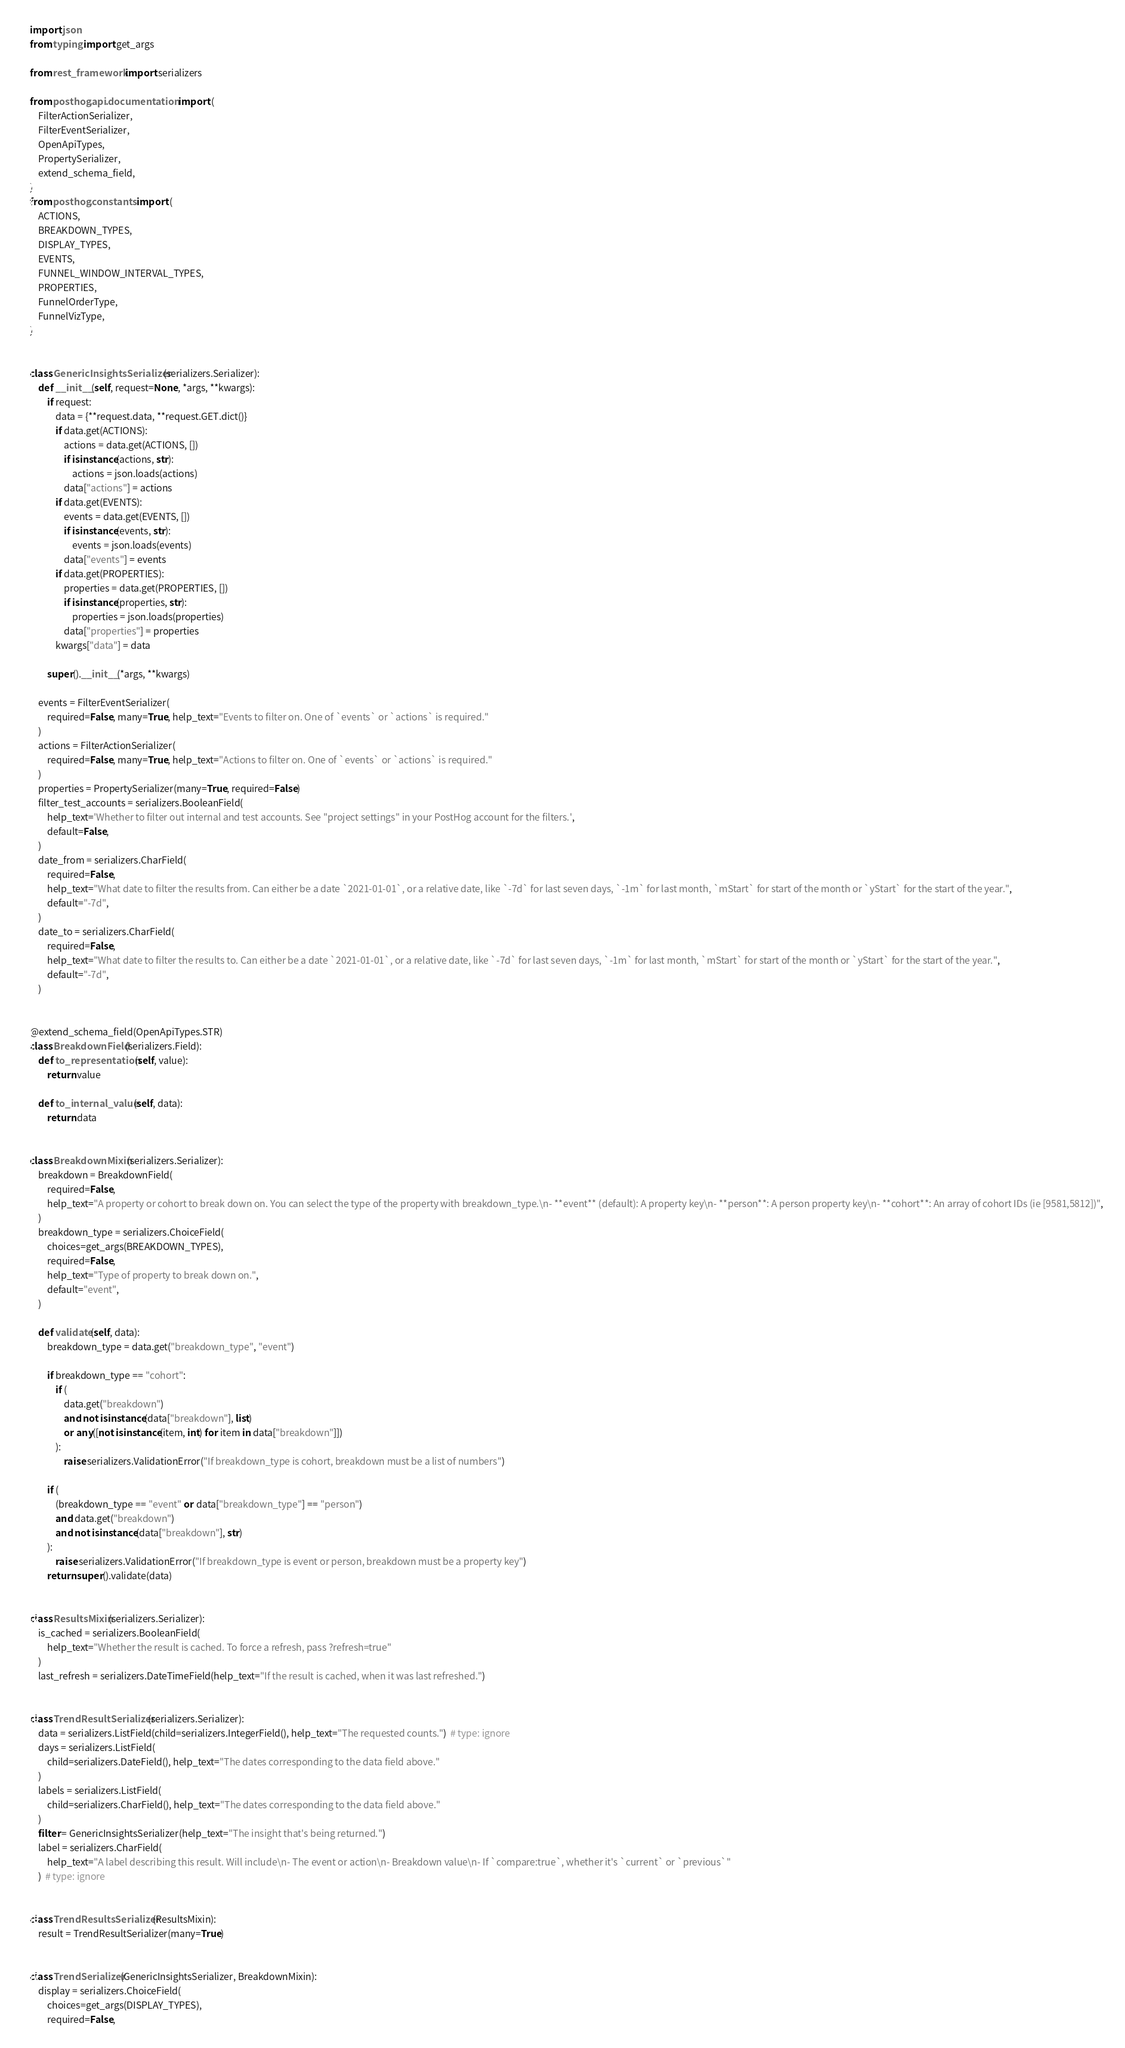<code> <loc_0><loc_0><loc_500><loc_500><_Python_>import json
from typing import get_args

from rest_framework import serializers

from posthog.api.documentation import (
    FilterActionSerializer,
    FilterEventSerializer,
    OpenApiTypes,
    PropertySerializer,
    extend_schema_field,
)
from posthog.constants import (
    ACTIONS,
    BREAKDOWN_TYPES,
    DISPLAY_TYPES,
    EVENTS,
    FUNNEL_WINDOW_INTERVAL_TYPES,
    PROPERTIES,
    FunnelOrderType,
    FunnelVizType,
)


class GenericInsightsSerializer(serializers.Serializer):
    def __init__(self, request=None, *args, **kwargs):
        if request:
            data = {**request.data, **request.GET.dict()}
            if data.get(ACTIONS):
                actions = data.get(ACTIONS, [])
                if isinstance(actions, str):
                    actions = json.loads(actions)
                data["actions"] = actions
            if data.get(EVENTS):
                events = data.get(EVENTS, [])
                if isinstance(events, str):
                    events = json.loads(events)
                data["events"] = events
            if data.get(PROPERTIES):
                properties = data.get(PROPERTIES, [])
                if isinstance(properties, str):
                    properties = json.loads(properties)
                data["properties"] = properties
            kwargs["data"] = data

        super().__init__(*args, **kwargs)

    events = FilterEventSerializer(
        required=False, many=True, help_text="Events to filter on. One of `events` or `actions` is required."
    )
    actions = FilterActionSerializer(
        required=False, many=True, help_text="Actions to filter on. One of `events` or `actions` is required."
    )
    properties = PropertySerializer(many=True, required=False)
    filter_test_accounts = serializers.BooleanField(
        help_text='Whether to filter out internal and test accounts. See "project settings" in your PostHog account for the filters.',
        default=False,
    )
    date_from = serializers.CharField(
        required=False,
        help_text="What date to filter the results from. Can either be a date `2021-01-01`, or a relative date, like `-7d` for last seven days, `-1m` for last month, `mStart` for start of the month or `yStart` for the start of the year.",
        default="-7d",
    )
    date_to = serializers.CharField(
        required=False,
        help_text="What date to filter the results to. Can either be a date `2021-01-01`, or a relative date, like `-7d` for last seven days, `-1m` for last month, `mStart` for start of the month or `yStart` for the start of the year.",
        default="-7d",
    )


@extend_schema_field(OpenApiTypes.STR)
class BreakdownField(serializers.Field):
    def to_representation(self, value):
        return value

    def to_internal_value(self, data):
        return data


class BreakdownMixin(serializers.Serializer):
    breakdown = BreakdownField(
        required=False,
        help_text="A property or cohort to break down on. You can select the type of the property with breakdown_type.\n- **event** (default): A property key\n- **person**: A person property key\n- **cohort**: An array of cohort IDs (ie [9581,5812])",
    )
    breakdown_type = serializers.ChoiceField(
        choices=get_args(BREAKDOWN_TYPES),
        required=False,
        help_text="Type of property to break down on.",
        default="event",
    )

    def validate(self, data):
        breakdown_type = data.get("breakdown_type", "event")

        if breakdown_type == "cohort":
            if (
                data.get("breakdown")
                and not isinstance(data["breakdown"], list)
                or any([not isinstance(item, int) for item in data["breakdown"]])
            ):
                raise serializers.ValidationError("If breakdown_type is cohort, breakdown must be a list of numbers")

        if (
            (breakdown_type == "event" or data["breakdown_type"] == "person")
            and data.get("breakdown")
            and not isinstance(data["breakdown"], str)
        ):
            raise serializers.ValidationError("If breakdown_type is event or person, breakdown must be a property key")
        return super().validate(data)


class ResultsMixin(serializers.Serializer):
    is_cached = serializers.BooleanField(
        help_text="Whether the result is cached. To force a refresh, pass ?refresh=true"
    )
    last_refresh = serializers.DateTimeField(help_text="If the result is cached, when it was last refreshed.")


class TrendResultSerializer(serializers.Serializer):
    data = serializers.ListField(child=serializers.IntegerField(), help_text="The requested counts.")  # type: ignore
    days = serializers.ListField(
        child=serializers.DateField(), help_text="The dates corresponding to the data field above."
    )
    labels = serializers.ListField(
        child=serializers.CharField(), help_text="The dates corresponding to the data field above."
    )
    filter = GenericInsightsSerializer(help_text="The insight that's being returned.")
    label = serializers.CharField(
        help_text="A label describing this result. Will include\n- The event or action\n- Breakdown value\n- If `compare:true`, whether it's `current` or `previous`"
    )  # type: ignore


class TrendResultsSerializer(ResultsMixin):
    result = TrendResultSerializer(many=True)


class TrendSerializer(GenericInsightsSerializer, BreakdownMixin):
    display = serializers.ChoiceField(
        choices=get_args(DISPLAY_TYPES),
        required=False,</code> 